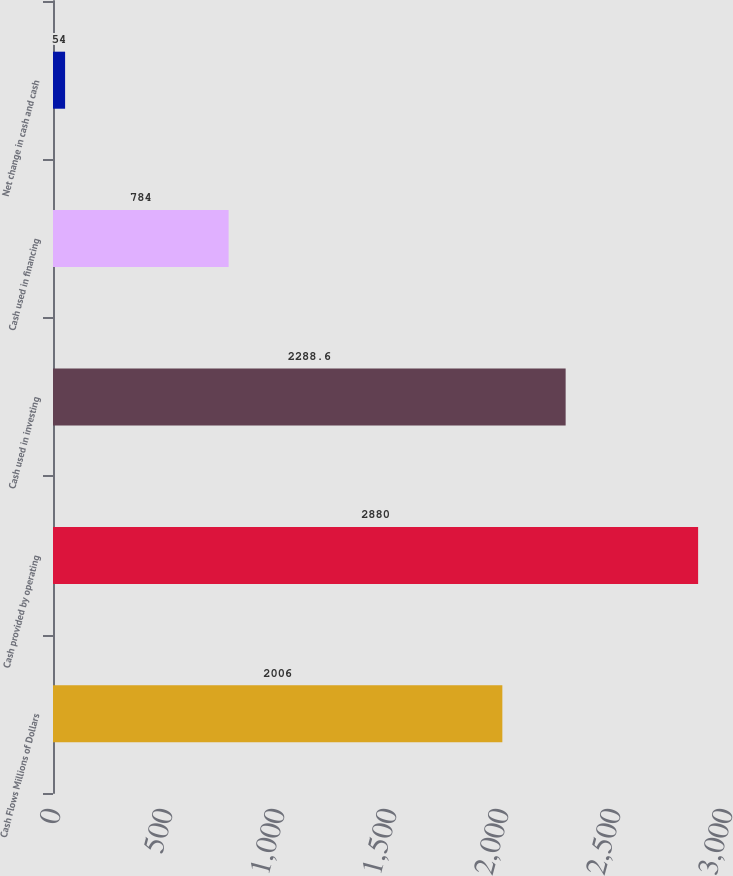Convert chart. <chart><loc_0><loc_0><loc_500><loc_500><bar_chart><fcel>Cash Flows Millions of Dollars<fcel>Cash provided by operating<fcel>Cash used in investing<fcel>Cash used in financing<fcel>Net change in cash and cash<nl><fcel>2006<fcel>2880<fcel>2288.6<fcel>784<fcel>54<nl></chart> 